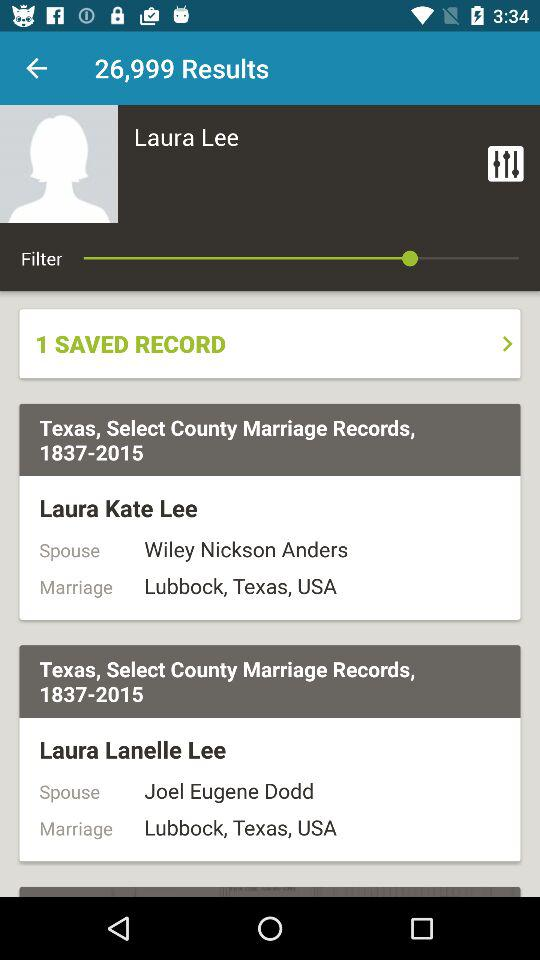What is the mentioned state? The mentioned state is Texas. 